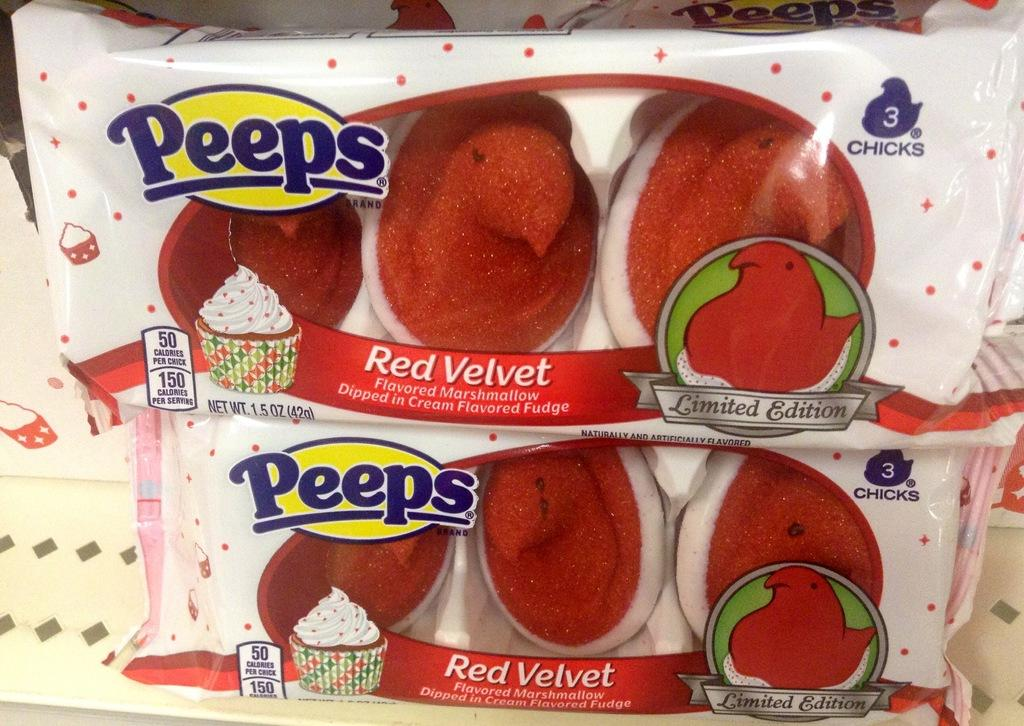What can be seen in the image related to food? There are two food packets in the image. What is the background of the food packets? The food packets are on a white surface. What information is present on the food packets? There is text on the food packets. What type of images are on the food packets? There are cartoon images on the food packets. What type of journey does the clover take in the image? There is no clover present in the image, so it cannot take a journey. 